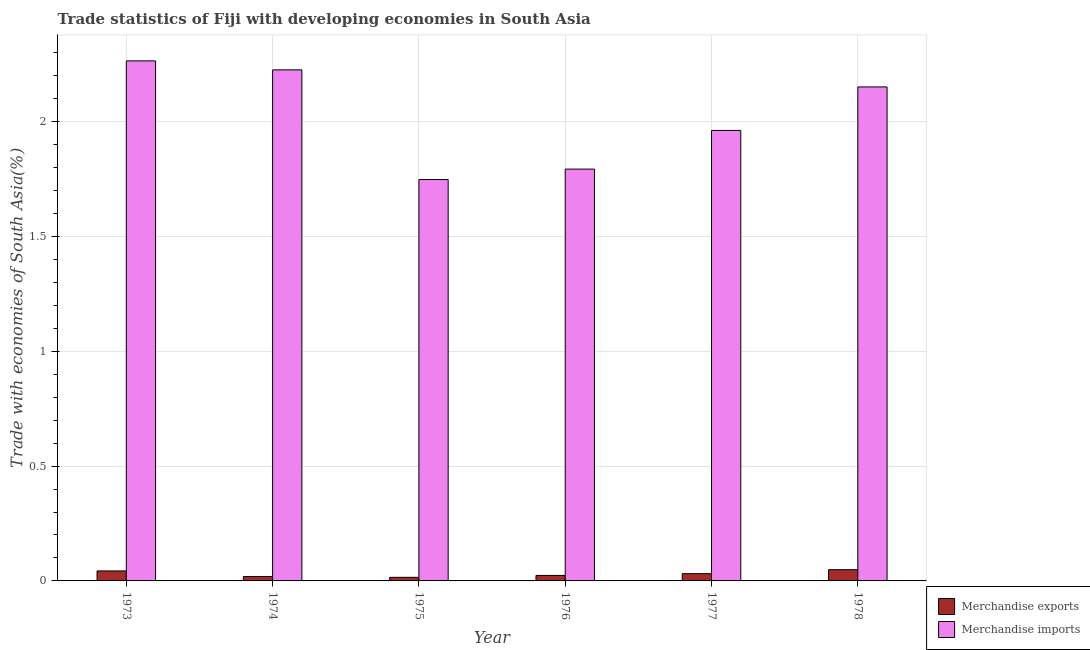Are the number of bars per tick equal to the number of legend labels?
Your response must be concise. Yes. How many bars are there on the 6th tick from the left?
Make the answer very short. 2. In how many cases, is the number of bars for a given year not equal to the number of legend labels?
Offer a terse response. 0. What is the merchandise exports in 1977?
Make the answer very short. 0.03. Across all years, what is the maximum merchandise imports?
Give a very brief answer. 2.26. Across all years, what is the minimum merchandise exports?
Provide a short and direct response. 0.02. In which year was the merchandise exports maximum?
Make the answer very short. 1978. In which year was the merchandise exports minimum?
Provide a short and direct response. 1975. What is the total merchandise imports in the graph?
Give a very brief answer. 12.14. What is the difference between the merchandise imports in 1975 and that in 1977?
Keep it short and to the point. -0.21. What is the difference between the merchandise exports in 1977 and the merchandise imports in 1978?
Make the answer very short. -0.02. What is the average merchandise exports per year?
Ensure brevity in your answer.  0.03. In the year 1977, what is the difference between the merchandise imports and merchandise exports?
Ensure brevity in your answer.  0. In how many years, is the merchandise exports greater than 0.8 %?
Give a very brief answer. 0. What is the ratio of the merchandise exports in 1976 to that in 1977?
Your response must be concise. 0.76. Is the merchandise exports in 1975 less than that in 1976?
Provide a succinct answer. Yes. What is the difference between the highest and the second highest merchandise exports?
Offer a terse response. 0.01. What is the difference between the highest and the lowest merchandise exports?
Make the answer very short. 0.03. In how many years, is the merchandise exports greater than the average merchandise exports taken over all years?
Provide a succinct answer. 3. How many bars are there?
Your answer should be very brief. 12. How many years are there in the graph?
Provide a short and direct response. 6. What is the difference between two consecutive major ticks on the Y-axis?
Give a very brief answer. 0.5. Are the values on the major ticks of Y-axis written in scientific E-notation?
Make the answer very short. No. Does the graph contain grids?
Your response must be concise. Yes. How are the legend labels stacked?
Give a very brief answer. Vertical. What is the title of the graph?
Your answer should be compact. Trade statistics of Fiji with developing economies in South Asia. What is the label or title of the Y-axis?
Your response must be concise. Trade with economies of South Asia(%). What is the Trade with economies of South Asia(%) in Merchandise exports in 1973?
Make the answer very short. 0.04. What is the Trade with economies of South Asia(%) in Merchandise imports in 1973?
Your answer should be compact. 2.26. What is the Trade with economies of South Asia(%) in Merchandise exports in 1974?
Your response must be concise. 0.02. What is the Trade with economies of South Asia(%) of Merchandise imports in 1974?
Give a very brief answer. 2.23. What is the Trade with economies of South Asia(%) of Merchandise exports in 1975?
Offer a terse response. 0.02. What is the Trade with economies of South Asia(%) in Merchandise imports in 1975?
Your response must be concise. 1.75. What is the Trade with economies of South Asia(%) of Merchandise exports in 1976?
Keep it short and to the point. 0.02. What is the Trade with economies of South Asia(%) in Merchandise imports in 1976?
Your response must be concise. 1.79. What is the Trade with economies of South Asia(%) in Merchandise exports in 1977?
Ensure brevity in your answer.  0.03. What is the Trade with economies of South Asia(%) in Merchandise imports in 1977?
Offer a terse response. 1.96. What is the Trade with economies of South Asia(%) in Merchandise exports in 1978?
Offer a very short reply. 0.05. What is the Trade with economies of South Asia(%) in Merchandise imports in 1978?
Provide a succinct answer. 2.15. Across all years, what is the maximum Trade with economies of South Asia(%) of Merchandise exports?
Provide a succinct answer. 0.05. Across all years, what is the maximum Trade with economies of South Asia(%) of Merchandise imports?
Offer a terse response. 2.26. Across all years, what is the minimum Trade with economies of South Asia(%) in Merchandise exports?
Your answer should be very brief. 0.02. Across all years, what is the minimum Trade with economies of South Asia(%) in Merchandise imports?
Make the answer very short. 1.75. What is the total Trade with economies of South Asia(%) in Merchandise exports in the graph?
Your response must be concise. 0.18. What is the total Trade with economies of South Asia(%) in Merchandise imports in the graph?
Your response must be concise. 12.14. What is the difference between the Trade with economies of South Asia(%) of Merchandise exports in 1973 and that in 1974?
Offer a very short reply. 0.02. What is the difference between the Trade with economies of South Asia(%) in Merchandise imports in 1973 and that in 1974?
Ensure brevity in your answer.  0.04. What is the difference between the Trade with economies of South Asia(%) in Merchandise exports in 1973 and that in 1975?
Ensure brevity in your answer.  0.03. What is the difference between the Trade with economies of South Asia(%) of Merchandise imports in 1973 and that in 1975?
Keep it short and to the point. 0.52. What is the difference between the Trade with economies of South Asia(%) in Merchandise exports in 1973 and that in 1976?
Offer a terse response. 0.02. What is the difference between the Trade with economies of South Asia(%) in Merchandise imports in 1973 and that in 1976?
Offer a very short reply. 0.47. What is the difference between the Trade with economies of South Asia(%) in Merchandise exports in 1973 and that in 1977?
Make the answer very short. 0.01. What is the difference between the Trade with economies of South Asia(%) in Merchandise imports in 1973 and that in 1977?
Your answer should be compact. 0.3. What is the difference between the Trade with economies of South Asia(%) in Merchandise exports in 1973 and that in 1978?
Provide a short and direct response. -0.01. What is the difference between the Trade with economies of South Asia(%) in Merchandise imports in 1973 and that in 1978?
Your answer should be very brief. 0.11. What is the difference between the Trade with economies of South Asia(%) in Merchandise exports in 1974 and that in 1975?
Your answer should be very brief. 0. What is the difference between the Trade with economies of South Asia(%) of Merchandise imports in 1974 and that in 1975?
Keep it short and to the point. 0.48. What is the difference between the Trade with economies of South Asia(%) in Merchandise exports in 1974 and that in 1976?
Your answer should be compact. -0. What is the difference between the Trade with economies of South Asia(%) of Merchandise imports in 1974 and that in 1976?
Your answer should be compact. 0.43. What is the difference between the Trade with economies of South Asia(%) of Merchandise exports in 1974 and that in 1977?
Your answer should be very brief. -0.01. What is the difference between the Trade with economies of South Asia(%) of Merchandise imports in 1974 and that in 1977?
Offer a very short reply. 0.26. What is the difference between the Trade with economies of South Asia(%) in Merchandise exports in 1974 and that in 1978?
Give a very brief answer. -0.03. What is the difference between the Trade with economies of South Asia(%) of Merchandise imports in 1974 and that in 1978?
Keep it short and to the point. 0.07. What is the difference between the Trade with economies of South Asia(%) in Merchandise exports in 1975 and that in 1976?
Offer a very short reply. -0.01. What is the difference between the Trade with economies of South Asia(%) in Merchandise imports in 1975 and that in 1976?
Ensure brevity in your answer.  -0.05. What is the difference between the Trade with economies of South Asia(%) in Merchandise exports in 1975 and that in 1977?
Give a very brief answer. -0.02. What is the difference between the Trade with economies of South Asia(%) of Merchandise imports in 1975 and that in 1977?
Your response must be concise. -0.21. What is the difference between the Trade with economies of South Asia(%) in Merchandise exports in 1975 and that in 1978?
Your response must be concise. -0.03. What is the difference between the Trade with economies of South Asia(%) in Merchandise imports in 1975 and that in 1978?
Make the answer very short. -0.4. What is the difference between the Trade with economies of South Asia(%) of Merchandise exports in 1976 and that in 1977?
Ensure brevity in your answer.  -0.01. What is the difference between the Trade with economies of South Asia(%) in Merchandise imports in 1976 and that in 1977?
Your answer should be very brief. -0.17. What is the difference between the Trade with economies of South Asia(%) in Merchandise exports in 1976 and that in 1978?
Provide a succinct answer. -0.03. What is the difference between the Trade with economies of South Asia(%) of Merchandise imports in 1976 and that in 1978?
Give a very brief answer. -0.36. What is the difference between the Trade with economies of South Asia(%) in Merchandise exports in 1977 and that in 1978?
Your response must be concise. -0.02. What is the difference between the Trade with economies of South Asia(%) of Merchandise imports in 1977 and that in 1978?
Ensure brevity in your answer.  -0.19. What is the difference between the Trade with economies of South Asia(%) in Merchandise exports in 1973 and the Trade with economies of South Asia(%) in Merchandise imports in 1974?
Provide a succinct answer. -2.18. What is the difference between the Trade with economies of South Asia(%) in Merchandise exports in 1973 and the Trade with economies of South Asia(%) in Merchandise imports in 1975?
Ensure brevity in your answer.  -1.7. What is the difference between the Trade with economies of South Asia(%) of Merchandise exports in 1973 and the Trade with economies of South Asia(%) of Merchandise imports in 1976?
Keep it short and to the point. -1.75. What is the difference between the Trade with economies of South Asia(%) in Merchandise exports in 1973 and the Trade with economies of South Asia(%) in Merchandise imports in 1977?
Keep it short and to the point. -1.92. What is the difference between the Trade with economies of South Asia(%) in Merchandise exports in 1973 and the Trade with economies of South Asia(%) in Merchandise imports in 1978?
Ensure brevity in your answer.  -2.11. What is the difference between the Trade with economies of South Asia(%) in Merchandise exports in 1974 and the Trade with economies of South Asia(%) in Merchandise imports in 1975?
Make the answer very short. -1.73. What is the difference between the Trade with economies of South Asia(%) in Merchandise exports in 1974 and the Trade with economies of South Asia(%) in Merchandise imports in 1976?
Give a very brief answer. -1.77. What is the difference between the Trade with economies of South Asia(%) in Merchandise exports in 1974 and the Trade with economies of South Asia(%) in Merchandise imports in 1977?
Your answer should be very brief. -1.94. What is the difference between the Trade with economies of South Asia(%) of Merchandise exports in 1974 and the Trade with economies of South Asia(%) of Merchandise imports in 1978?
Your answer should be very brief. -2.13. What is the difference between the Trade with economies of South Asia(%) of Merchandise exports in 1975 and the Trade with economies of South Asia(%) of Merchandise imports in 1976?
Offer a very short reply. -1.78. What is the difference between the Trade with economies of South Asia(%) of Merchandise exports in 1975 and the Trade with economies of South Asia(%) of Merchandise imports in 1977?
Your answer should be very brief. -1.95. What is the difference between the Trade with economies of South Asia(%) in Merchandise exports in 1975 and the Trade with economies of South Asia(%) in Merchandise imports in 1978?
Keep it short and to the point. -2.14. What is the difference between the Trade with economies of South Asia(%) in Merchandise exports in 1976 and the Trade with economies of South Asia(%) in Merchandise imports in 1977?
Make the answer very short. -1.94. What is the difference between the Trade with economies of South Asia(%) of Merchandise exports in 1976 and the Trade with economies of South Asia(%) of Merchandise imports in 1978?
Offer a terse response. -2.13. What is the difference between the Trade with economies of South Asia(%) in Merchandise exports in 1977 and the Trade with economies of South Asia(%) in Merchandise imports in 1978?
Your answer should be compact. -2.12. What is the average Trade with economies of South Asia(%) of Merchandise exports per year?
Your answer should be very brief. 0.03. What is the average Trade with economies of South Asia(%) in Merchandise imports per year?
Give a very brief answer. 2.02. In the year 1973, what is the difference between the Trade with economies of South Asia(%) in Merchandise exports and Trade with economies of South Asia(%) in Merchandise imports?
Your answer should be very brief. -2.22. In the year 1974, what is the difference between the Trade with economies of South Asia(%) in Merchandise exports and Trade with economies of South Asia(%) in Merchandise imports?
Offer a very short reply. -2.21. In the year 1975, what is the difference between the Trade with economies of South Asia(%) in Merchandise exports and Trade with economies of South Asia(%) in Merchandise imports?
Provide a succinct answer. -1.73. In the year 1976, what is the difference between the Trade with economies of South Asia(%) in Merchandise exports and Trade with economies of South Asia(%) in Merchandise imports?
Your answer should be compact. -1.77. In the year 1977, what is the difference between the Trade with economies of South Asia(%) of Merchandise exports and Trade with economies of South Asia(%) of Merchandise imports?
Keep it short and to the point. -1.93. In the year 1978, what is the difference between the Trade with economies of South Asia(%) in Merchandise exports and Trade with economies of South Asia(%) in Merchandise imports?
Keep it short and to the point. -2.1. What is the ratio of the Trade with economies of South Asia(%) in Merchandise exports in 1973 to that in 1974?
Give a very brief answer. 2.27. What is the ratio of the Trade with economies of South Asia(%) in Merchandise imports in 1973 to that in 1974?
Keep it short and to the point. 1.02. What is the ratio of the Trade with economies of South Asia(%) in Merchandise exports in 1973 to that in 1975?
Your answer should be compact. 2.79. What is the ratio of the Trade with economies of South Asia(%) in Merchandise imports in 1973 to that in 1975?
Your answer should be compact. 1.3. What is the ratio of the Trade with economies of South Asia(%) in Merchandise exports in 1973 to that in 1976?
Make the answer very short. 1.82. What is the ratio of the Trade with economies of South Asia(%) of Merchandise imports in 1973 to that in 1976?
Your answer should be very brief. 1.26. What is the ratio of the Trade with economies of South Asia(%) of Merchandise exports in 1973 to that in 1977?
Your response must be concise. 1.38. What is the ratio of the Trade with economies of South Asia(%) in Merchandise imports in 1973 to that in 1977?
Provide a succinct answer. 1.15. What is the ratio of the Trade with economies of South Asia(%) of Merchandise exports in 1973 to that in 1978?
Make the answer very short. 0.89. What is the ratio of the Trade with economies of South Asia(%) in Merchandise imports in 1973 to that in 1978?
Your response must be concise. 1.05. What is the ratio of the Trade with economies of South Asia(%) of Merchandise exports in 1974 to that in 1975?
Provide a short and direct response. 1.23. What is the ratio of the Trade with economies of South Asia(%) of Merchandise imports in 1974 to that in 1975?
Offer a terse response. 1.27. What is the ratio of the Trade with economies of South Asia(%) in Merchandise exports in 1974 to that in 1976?
Ensure brevity in your answer.  0.8. What is the ratio of the Trade with economies of South Asia(%) in Merchandise imports in 1974 to that in 1976?
Make the answer very short. 1.24. What is the ratio of the Trade with economies of South Asia(%) of Merchandise exports in 1974 to that in 1977?
Ensure brevity in your answer.  0.61. What is the ratio of the Trade with economies of South Asia(%) in Merchandise imports in 1974 to that in 1977?
Offer a terse response. 1.13. What is the ratio of the Trade with economies of South Asia(%) of Merchandise exports in 1974 to that in 1978?
Ensure brevity in your answer.  0.39. What is the ratio of the Trade with economies of South Asia(%) in Merchandise imports in 1974 to that in 1978?
Your response must be concise. 1.03. What is the ratio of the Trade with economies of South Asia(%) of Merchandise exports in 1975 to that in 1976?
Ensure brevity in your answer.  0.65. What is the ratio of the Trade with economies of South Asia(%) of Merchandise imports in 1975 to that in 1976?
Your response must be concise. 0.97. What is the ratio of the Trade with economies of South Asia(%) in Merchandise exports in 1975 to that in 1977?
Your response must be concise. 0.49. What is the ratio of the Trade with economies of South Asia(%) of Merchandise imports in 1975 to that in 1977?
Offer a very short reply. 0.89. What is the ratio of the Trade with economies of South Asia(%) of Merchandise exports in 1975 to that in 1978?
Provide a short and direct response. 0.32. What is the ratio of the Trade with economies of South Asia(%) of Merchandise imports in 1975 to that in 1978?
Give a very brief answer. 0.81. What is the ratio of the Trade with economies of South Asia(%) of Merchandise exports in 1976 to that in 1977?
Your answer should be very brief. 0.76. What is the ratio of the Trade with economies of South Asia(%) of Merchandise imports in 1976 to that in 1977?
Provide a short and direct response. 0.91. What is the ratio of the Trade with economies of South Asia(%) of Merchandise exports in 1976 to that in 1978?
Keep it short and to the point. 0.49. What is the ratio of the Trade with economies of South Asia(%) in Merchandise imports in 1976 to that in 1978?
Offer a terse response. 0.83. What is the ratio of the Trade with economies of South Asia(%) in Merchandise exports in 1977 to that in 1978?
Give a very brief answer. 0.65. What is the ratio of the Trade with economies of South Asia(%) in Merchandise imports in 1977 to that in 1978?
Keep it short and to the point. 0.91. What is the difference between the highest and the second highest Trade with economies of South Asia(%) in Merchandise exports?
Your answer should be very brief. 0.01. What is the difference between the highest and the second highest Trade with economies of South Asia(%) of Merchandise imports?
Keep it short and to the point. 0.04. What is the difference between the highest and the lowest Trade with economies of South Asia(%) in Merchandise exports?
Make the answer very short. 0.03. What is the difference between the highest and the lowest Trade with economies of South Asia(%) of Merchandise imports?
Provide a succinct answer. 0.52. 